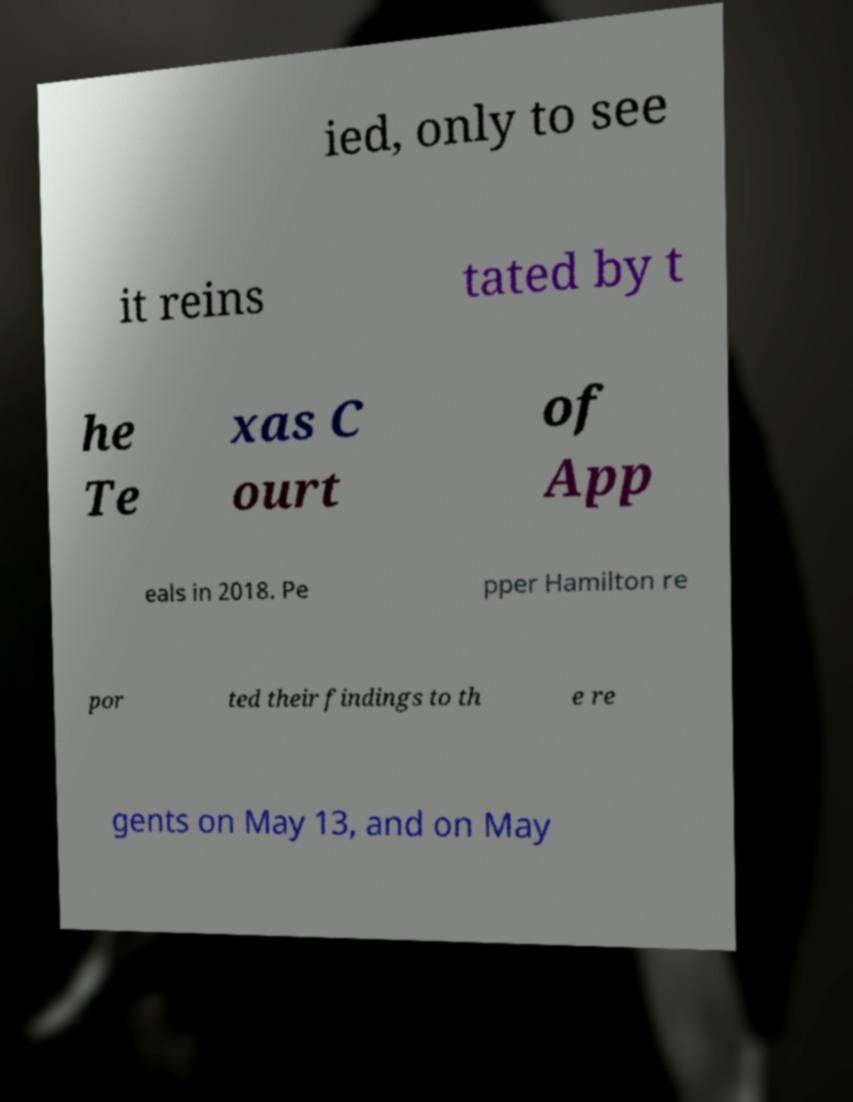Please read and relay the text visible in this image. What does it say? ied, only to see it reins tated by t he Te xas C ourt of App eals in 2018. Pe pper Hamilton re por ted their findings to th e re gents on May 13, and on May 